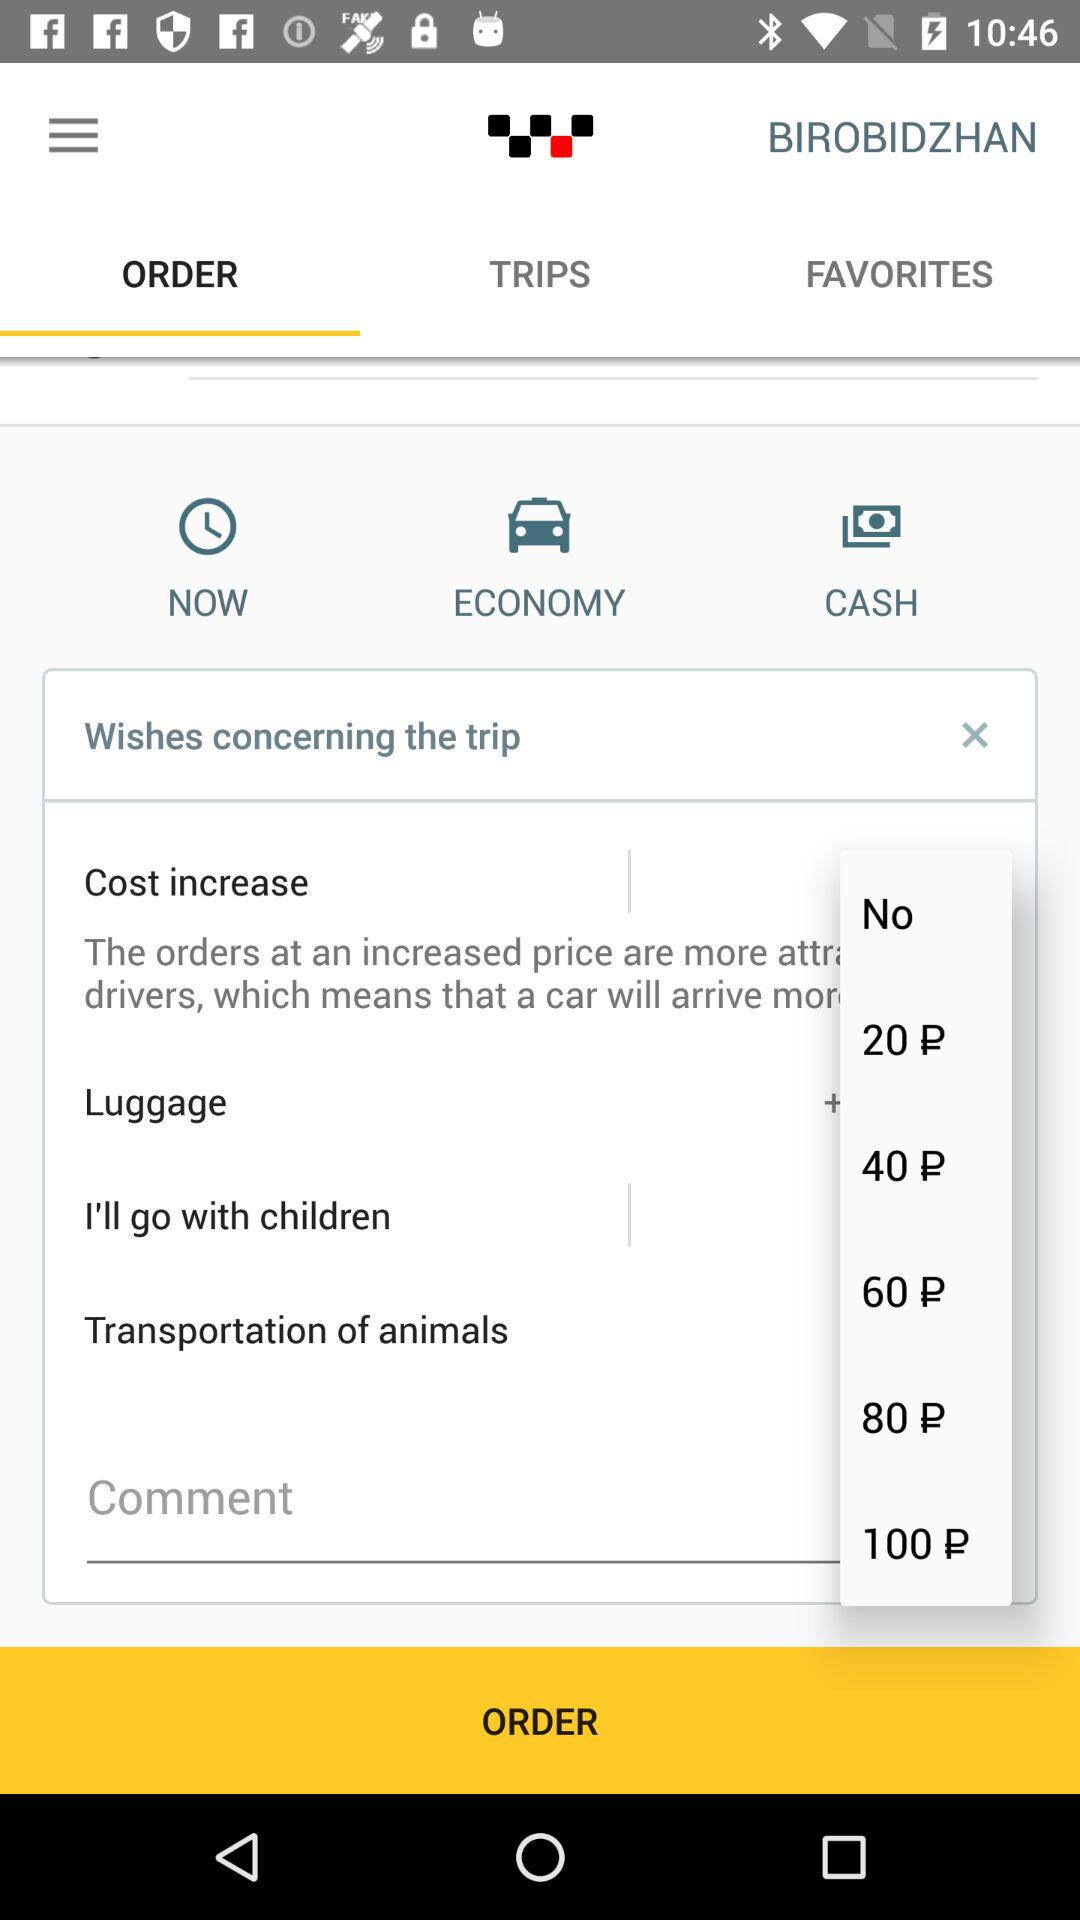Which tab has been selected? The selected tab is "ORDER". 